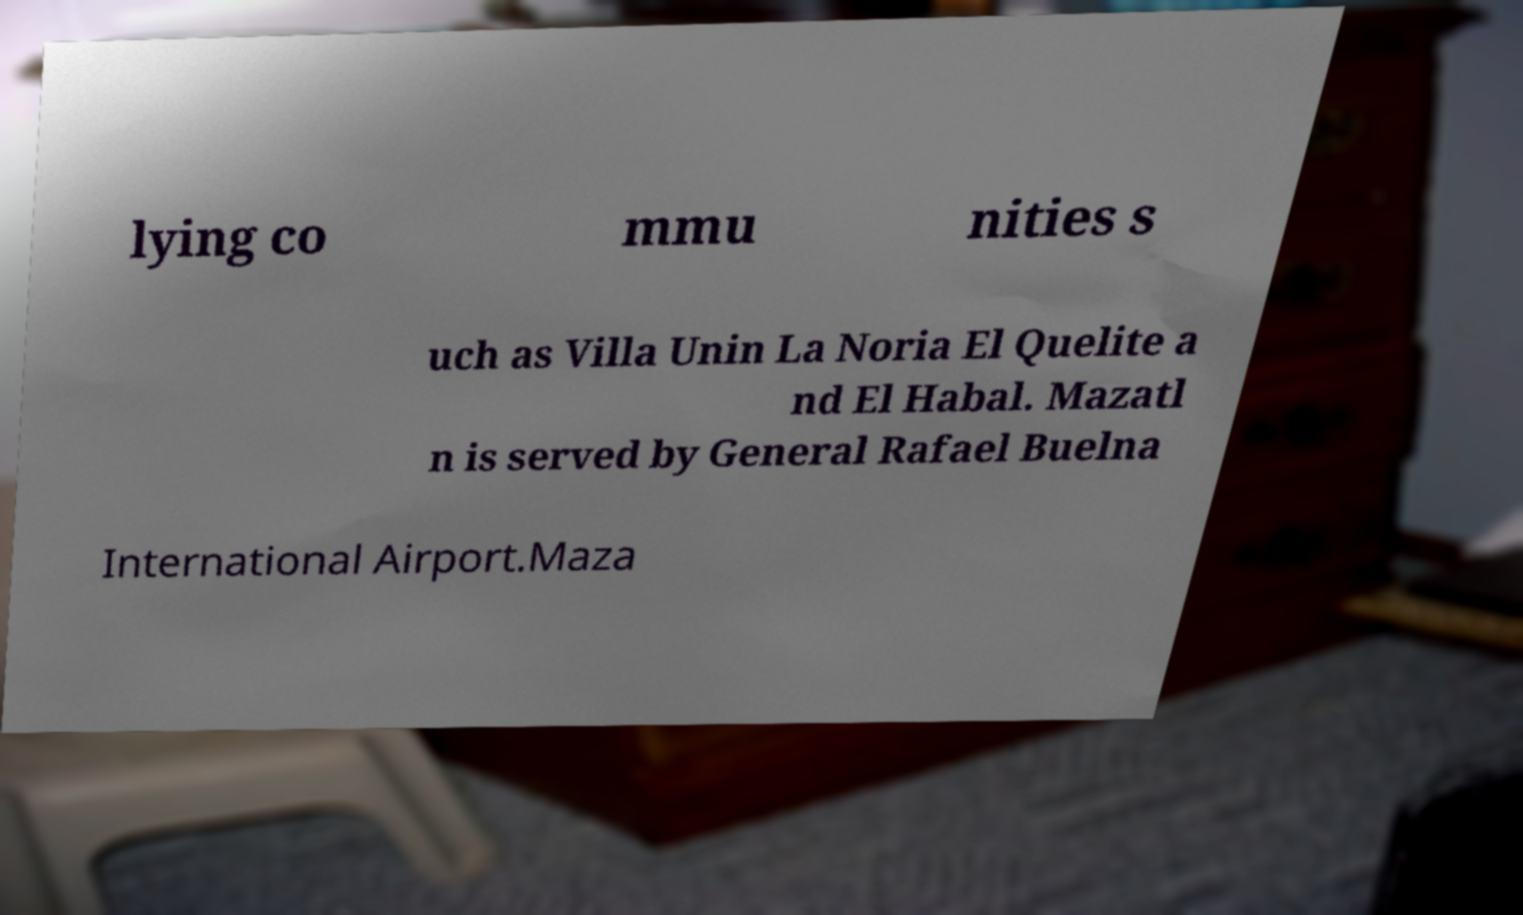Can you read and provide the text displayed in the image?This photo seems to have some interesting text. Can you extract and type it out for me? lying co mmu nities s uch as Villa Unin La Noria El Quelite a nd El Habal. Mazatl n is served by General Rafael Buelna International Airport.Maza 